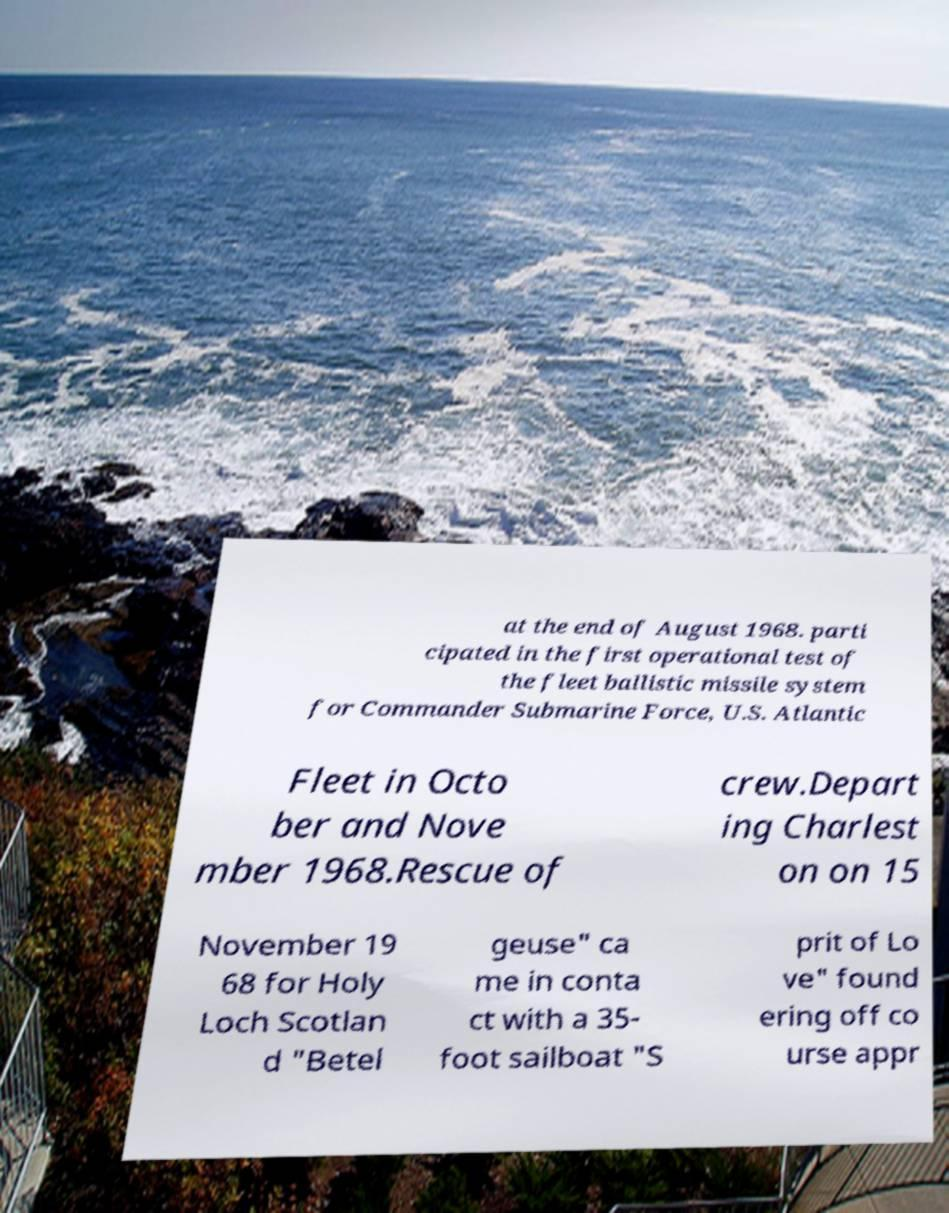For documentation purposes, I need the text within this image transcribed. Could you provide that? at the end of August 1968. parti cipated in the first operational test of the fleet ballistic missile system for Commander Submarine Force, U.S. Atlantic Fleet in Octo ber and Nove mber 1968.Rescue of crew.Depart ing Charlest on on 15 November 19 68 for Holy Loch Scotlan d "Betel geuse" ca me in conta ct with a 35- foot sailboat "S prit of Lo ve" found ering off co urse appr 